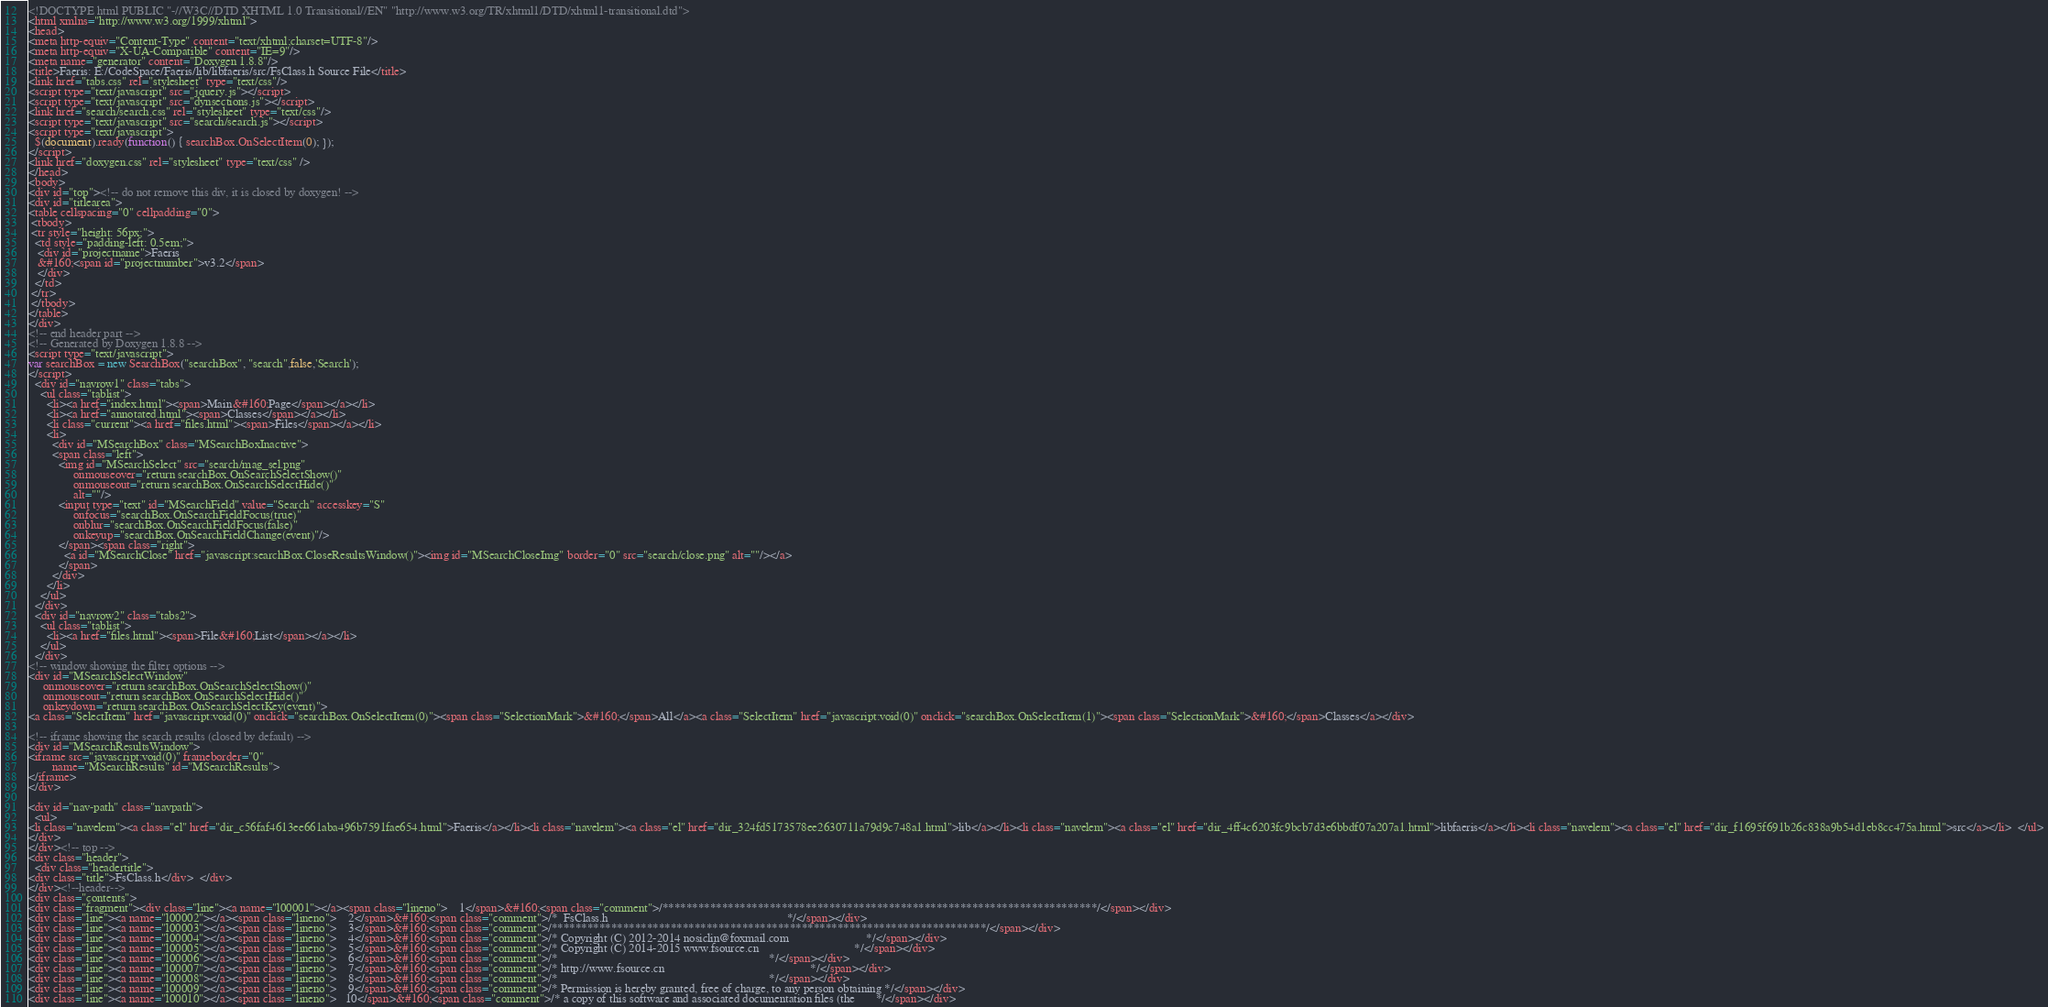Convert code to text. <code><loc_0><loc_0><loc_500><loc_500><_HTML_><!DOCTYPE html PUBLIC "-//W3C//DTD XHTML 1.0 Transitional//EN" "http://www.w3.org/TR/xhtml1/DTD/xhtml1-transitional.dtd">
<html xmlns="http://www.w3.org/1999/xhtml">
<head>
<meta http-equiv="Content-Type" content="text/xhtml;charset=UTF-8"/>
<meta http-equiv="X-UA-Compatible" content="IE=9"/>
<meta name="generator" content="Doxygen 1.8.8"/>
<title>Faeris: E:/CodeSpace/Faeris/lib/libfaeris/src/FsClass.h Source File</title>
<link href="tabs.css" rel="stylesheet" type="text/css"/>
<script type="text/javascript" src="jquery.js"></script>
<script type="text/javascript" src="dynsections.js"></script>
<link href="search/search.css" rel="stylesheet" type="text/css"/>
<script type="text/javascript" src="search/search.js"></script>
<script type="text/javascript">
  $(document).ready(function() { searchBox.OnSelectItem(0); });
</script>
<link href="doxygen.css" rel="stylesheet" type="text/css" />
</head>
<body>
<div id="top"><!-- do not remove this div, it is closed by doxygen! -->
<div id="titlearea">
<table cellspacing="0" cellpadding="0">
 <tbody>
 <tr style="height: 56px;">
  <td style="padding-left: 0.5em;">
   <div id="projectname">Faeris
   &#160;<span id="projectnumber">v3.2</span>
   </div>
  </td>
 </tr>
 </tbody>
</table>
</div>
<!-- end header part -->
<!-- Generated by Doxygen 1.8.8 -->
<script type="text/javascript">
var searchBox = new SearchBox("searchBox", "search",false,'Search');
</script>
  <div id="navrow1" class="tabs">
    <ul class="tablist">
      <li><a href="index.html"><span>Main&#160;Page</span></a></li>
      <li><a href="annotated.html"><span>Classes</span></a></li>
      <li class="current"><a href="files.html"><span>Files</span></a></li>
      <li>
        <div id="MSearchBox" class="MSearchBoxInactive">
        <span class="left">
          <img id="MSearchSelect" src="search/mag_sel.png"
               onmouseover="return searchBox.OnSearchSelectShow()"
               onmouseout="return searchBox.OnSearchSelectHide()"
               alt=""/>
          <input type="text" id="MSearchField" value="Search" accesskey="S"
               onfocus="searchBox.OnSearchFieldFocus(true)" 
               onblur="searchBox.OnSearchFieldFocus(false)" 
               onkeyup="searchBox.OnSearchFieldChange(event)"/>
          </span><span class="right">
            <a id="MSearchClose" href="javascript:searchBox.CloseResultsWindow()"><img id="MSearchCloseImg" border="0" src="search/close.png" alt=""/></a>
          </span>
        </div>
      </li>
    </ul>
  </div>
  <div id="navrow2" class="tabs2">
    <ul class="tablist">
      <li><a href="files.html"><span>File&#160;List</span></a></li>
    </ul>
  </div>
<!-- window showing the filter options -->
<div id="MSearchSelectWindow"
     onmouseover="return searchBox.OnSearchSelectShow()"
     onmouseout="return searchBox.OnSearchSelectHide()"
     onkeydown="return searchBox.OnSearchSelectKey(event)">
<a class="SelectItem" href="javascript:void(0)" onclick="searchBox.OnSelectItem(0)"><span class="SelectionMark">&#160;</span>All</a><a class="SelectItem" href="javascript:void(0)" onclick="searchBox.OnSelectItem(1)"><span class="SelectionMark">&#160;</span>Classes</a></div>

<!-- iframe showing the search results (closed by default) -->
<div id="MSearchResultsWindow">
<iframe src="javascript:void(0)" frameborder="0" 
        name="MSearchResults" id="MSearchResults">
</iframe>
</div>

<div id="nav-path" class="navpath">
  <ul>
<li class="navelem"><a class="el" href="dir_c56faf4613ee661aba496b7591fae654.html">Faeris</a></li><li class="navelem"><a class="el" href="dir_324fd5173578ee2630711a79d9c748a1.html">lib</a></li><li class="navelem"><a class="el" href="dir_4ff4c6203fc9bcb7d3e6bbdf07a207a1.html">libfaeris</a></li><li class="navelem"><a class="el" href="dir_f1695f691b26c838a9b54d1eb8cc475a.html">src</a></li>  </ul>
</div>
</div><!-- top -->
<div class="header">
  <div class="headertitle">
<div class="title">FsClass.h</div>  </div>
</div><!--header-->
<div class="contents">
<div class="fragment"><div class="line"><a name="l00001"></a><span class="lineno">    1</span>&#160;<span class="comment">/*************************************************************************/</span></div>
<div class="line"><a name="l00002"></a><span class="lineno">    2</span>&#160;<span class="comment">/*  FsClass.h                                                            */</span></div>
<div class="line"><a name="l00003"></a><span class="lineno">    3</span>&#160;<span class="comment">/*************************************************************************/</span></div>
<div class="line"><a name="l00004"></a><span class="lineno">    4</span>&#160;<span class="comment">/* Copyright (C) 2012-2014 nosiclin@foxmail.com                          */</span></div>
<div class="line"><a name="l00005"></a><span class="lineno">    5</span>&#160;<span class="comment">/* Copyright (C) 2014-2015 www.fsource.cn                                */</span></div>
<div class="line"><a name="l00006"></a><span class="lineno">    6</span>&#160;<span class="comment">/*                                                                       */</span></div>
<div class="line"><a name="l00007"></a><span class="lineno">    7</span>&#160;<span class="comment">/* http://www.fsource.cn                                                 */</span></div>
<div class="line"><a name="l00008"></a><span class="lineno">    8</span>&#160;<span class="comment">/*                                                                       */</span></div>
<div class="line"><a name="l00009"></a><span class="lineno">    9</span>&#160;<span class="comment">/* Permission is hereby granted, free of charge, to any person obtaining */</span></div>
<div class="line"><a name="l00010"></a><span class="lineno">   10</span>&#160;<span class="comment">/* a copy of this software and associated documentation files (the       */</span></div></code> 